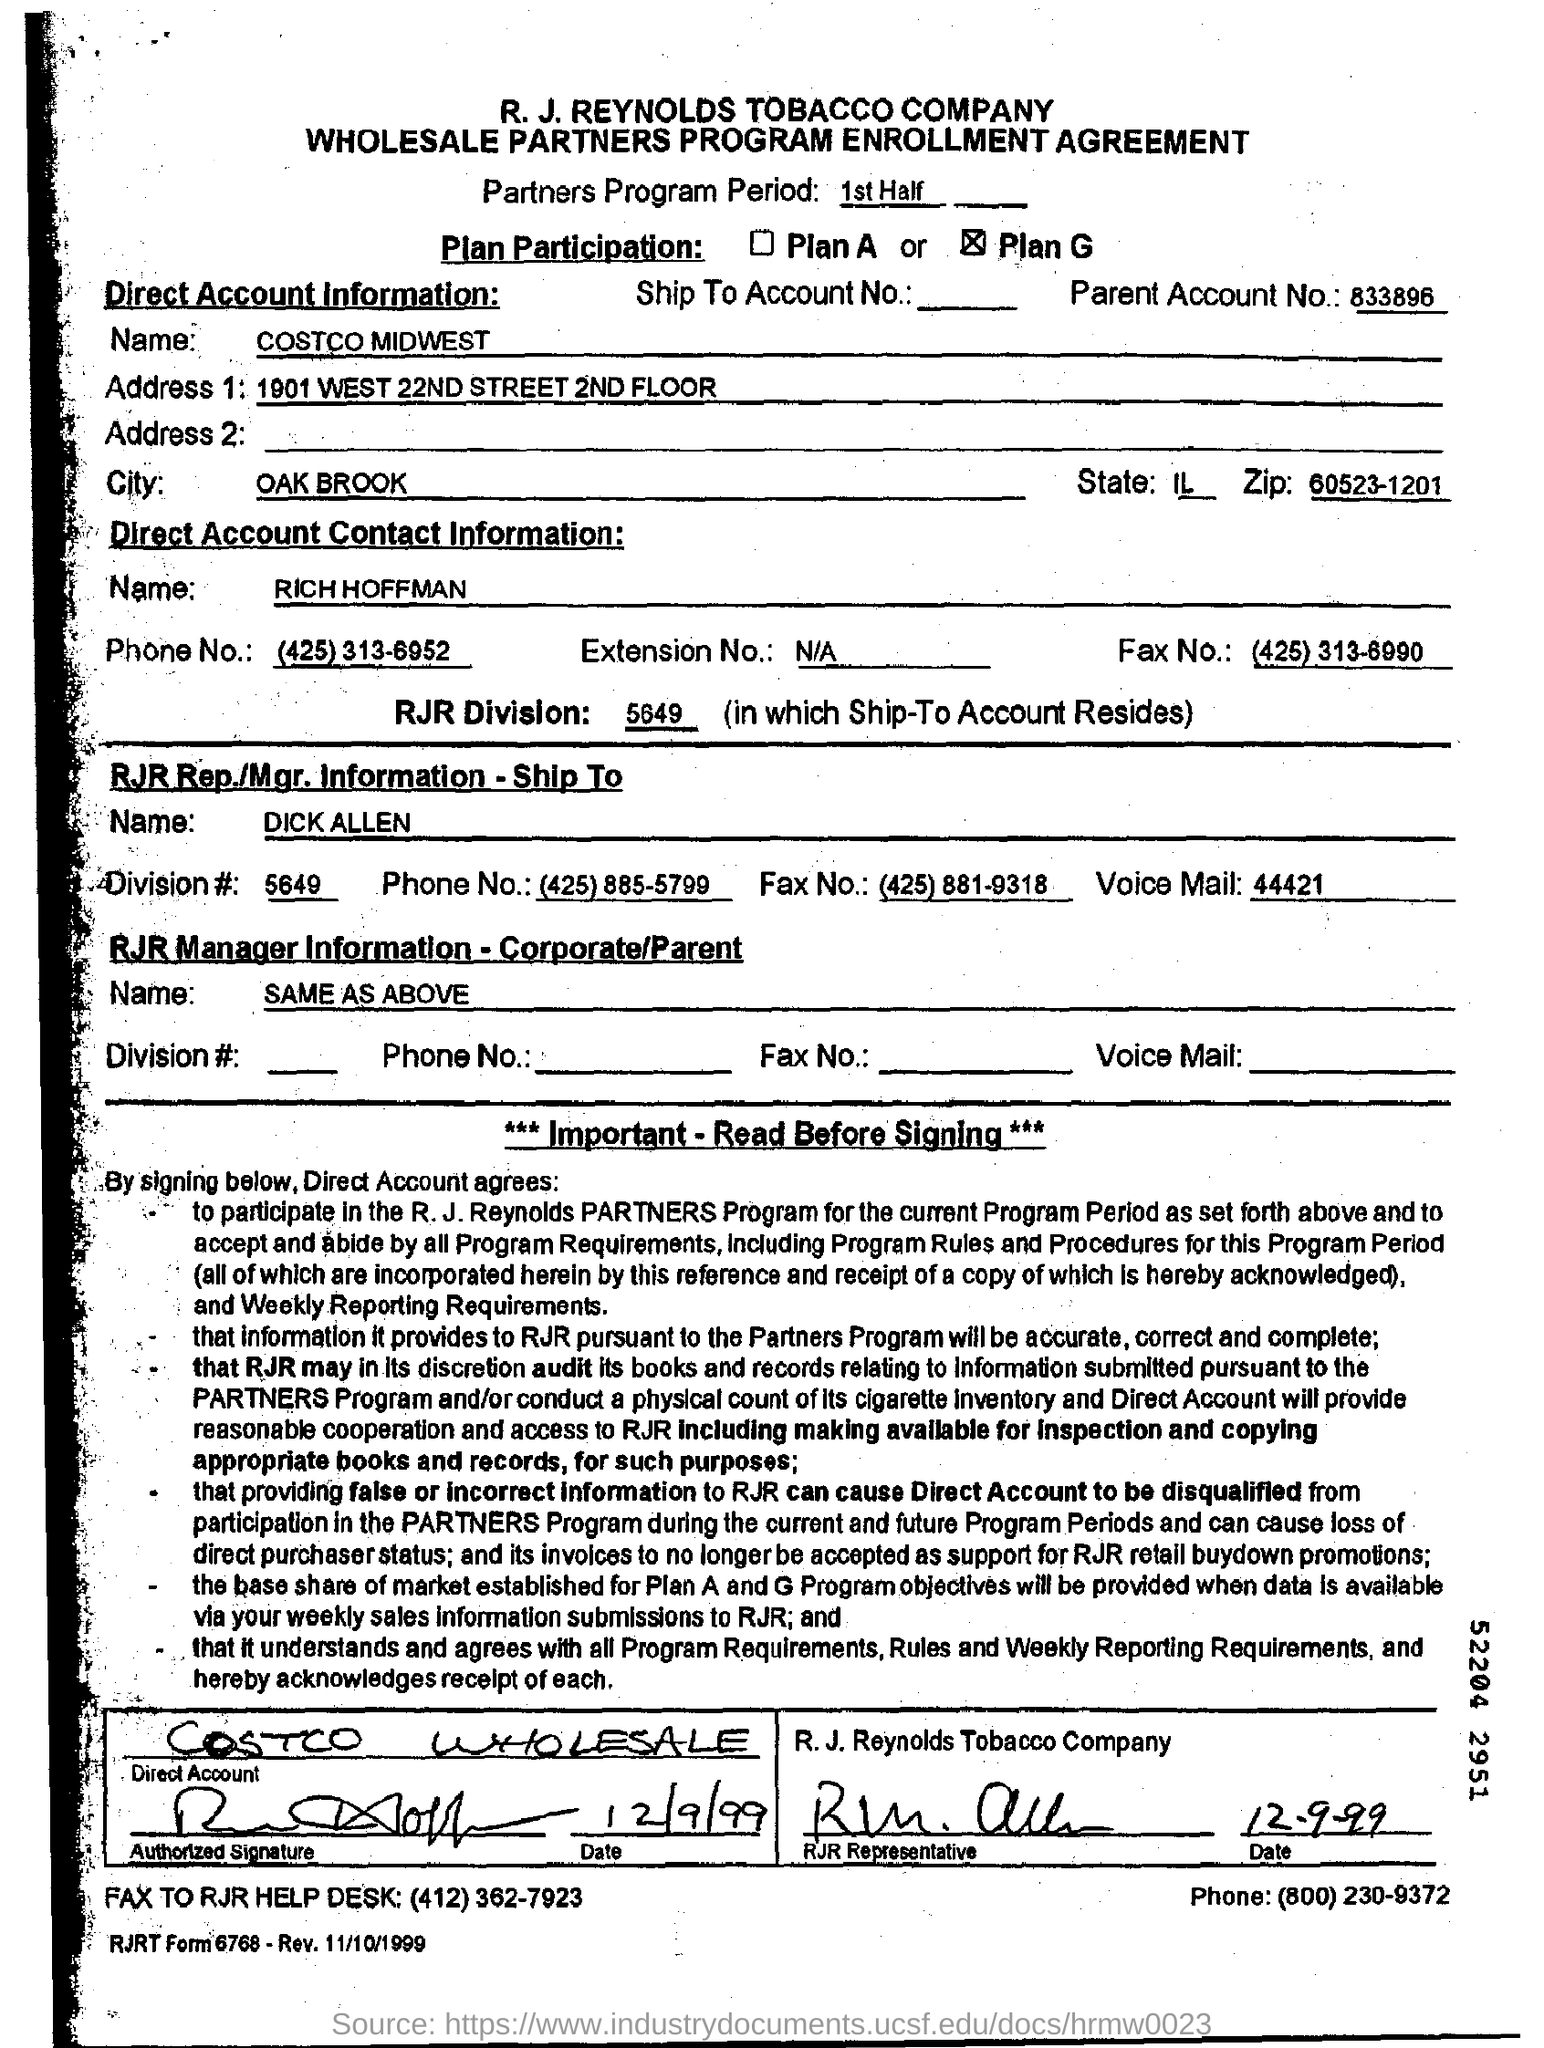What is the parent account number?
Ensure brevity in your answer.  833896. What is the name given in Direct Account Information?
Provide a succinct answer. COSTCO MIDWEST. What is the name of RJR Rep./Mgr.?
Ensure brevity in your answer.  DICK ALLEN. 